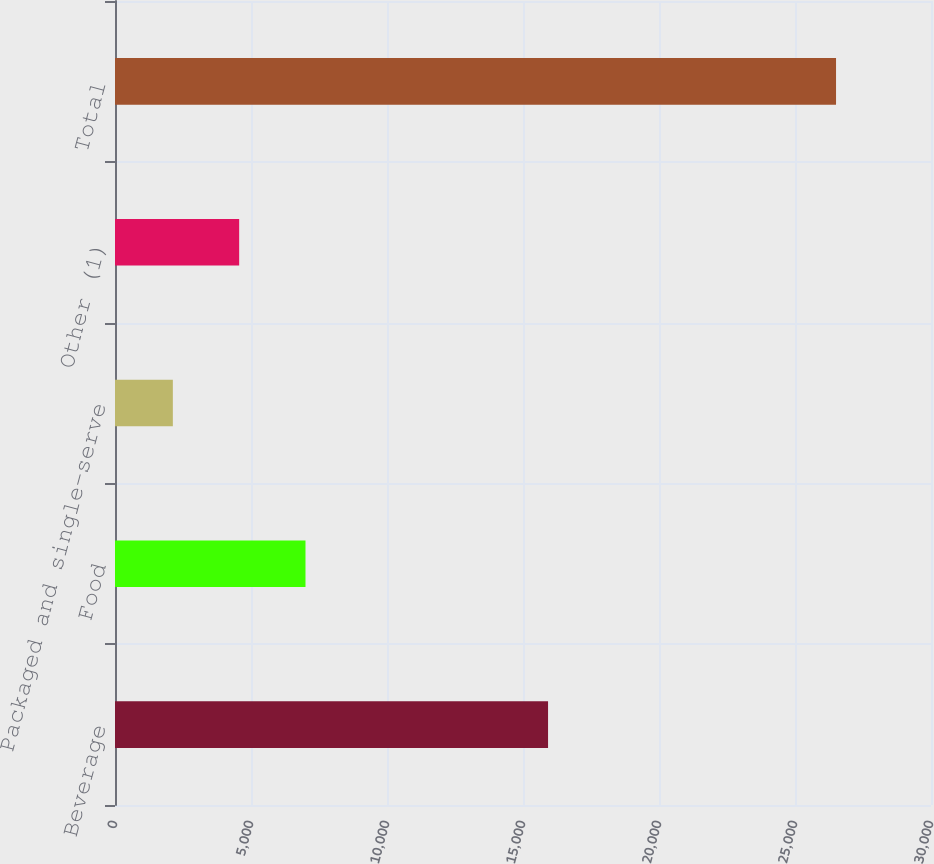Convert chart. <chart><loc_0><loc_0><loc_500><loc_500><bar_chart><fcel>Beverage<fcel>Food<fcel>Packaged and single-serve<fcel>Other (1)<fcel>Total<nl><fcel>15921.2<fcel>7003.16<fcel>2126.8<fcel>4564.98<fcel>26508.6<nl></chart> 